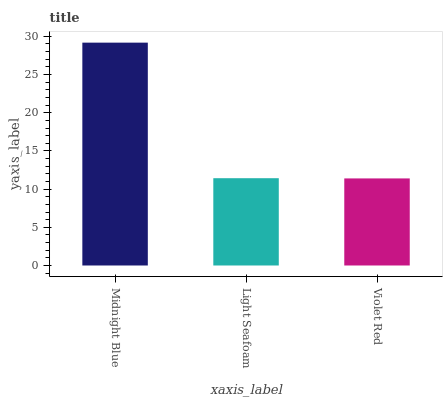Is Violet Red the minimum?
Answer yes or no. Yes. Is Midnight Blue the maximum?
Answer yes or no. Yes. Is Light Seafoam the minimum?
Answer yes or no. No. Is Light Seafoam the maximum?
Answer yes or no. No. Is Midnight Blue greater than Light Seafoam?
Answer yes or no. Yes. Is Light Seafoam less than Midnight Blue?
Answer yes or no. Yes. Is Light Seafoam greater than Midnight Blue?
Answer yes or no. No. Is Midnight Blue less than Light Seafoam?
Answer yes or no. No. Is Light Seafoam the high median?
Answer yes or no. Yes. Is Light Seafoam the low median?
Answer yes or no. Yes. Is Midnight Blue the high median?
Answer yes or no. No. Is Midnight Blue the low median?
Answer yes or no. No. 